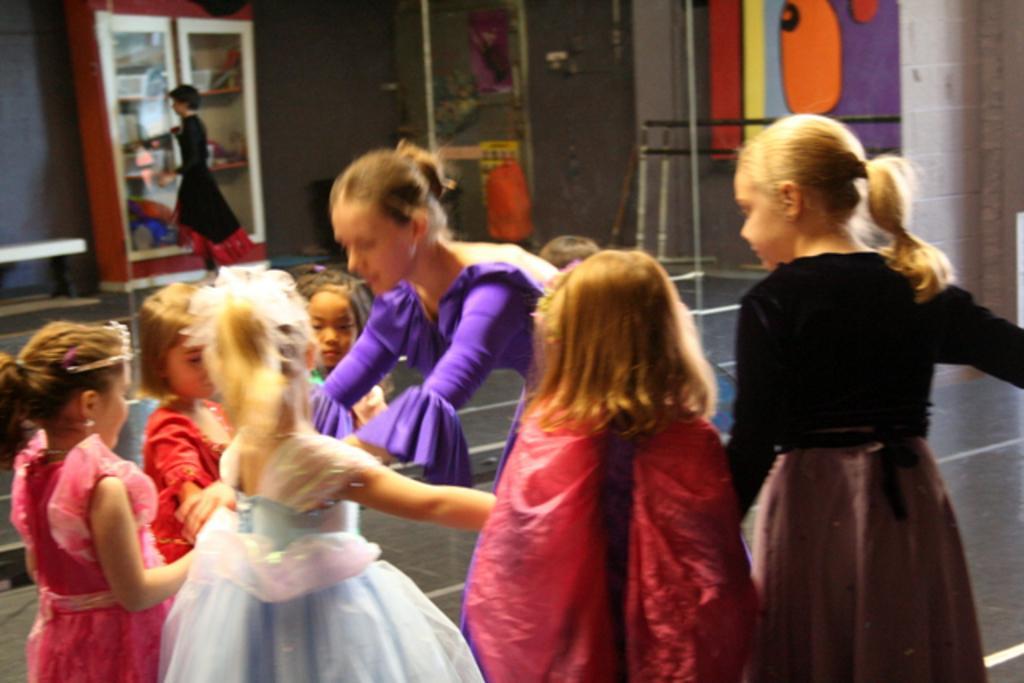In one or two sentences, can you explain what this image depicts? In this image there are group of girls standing together along with women, beside them there is a shelf with some things in it and some wall paints. 